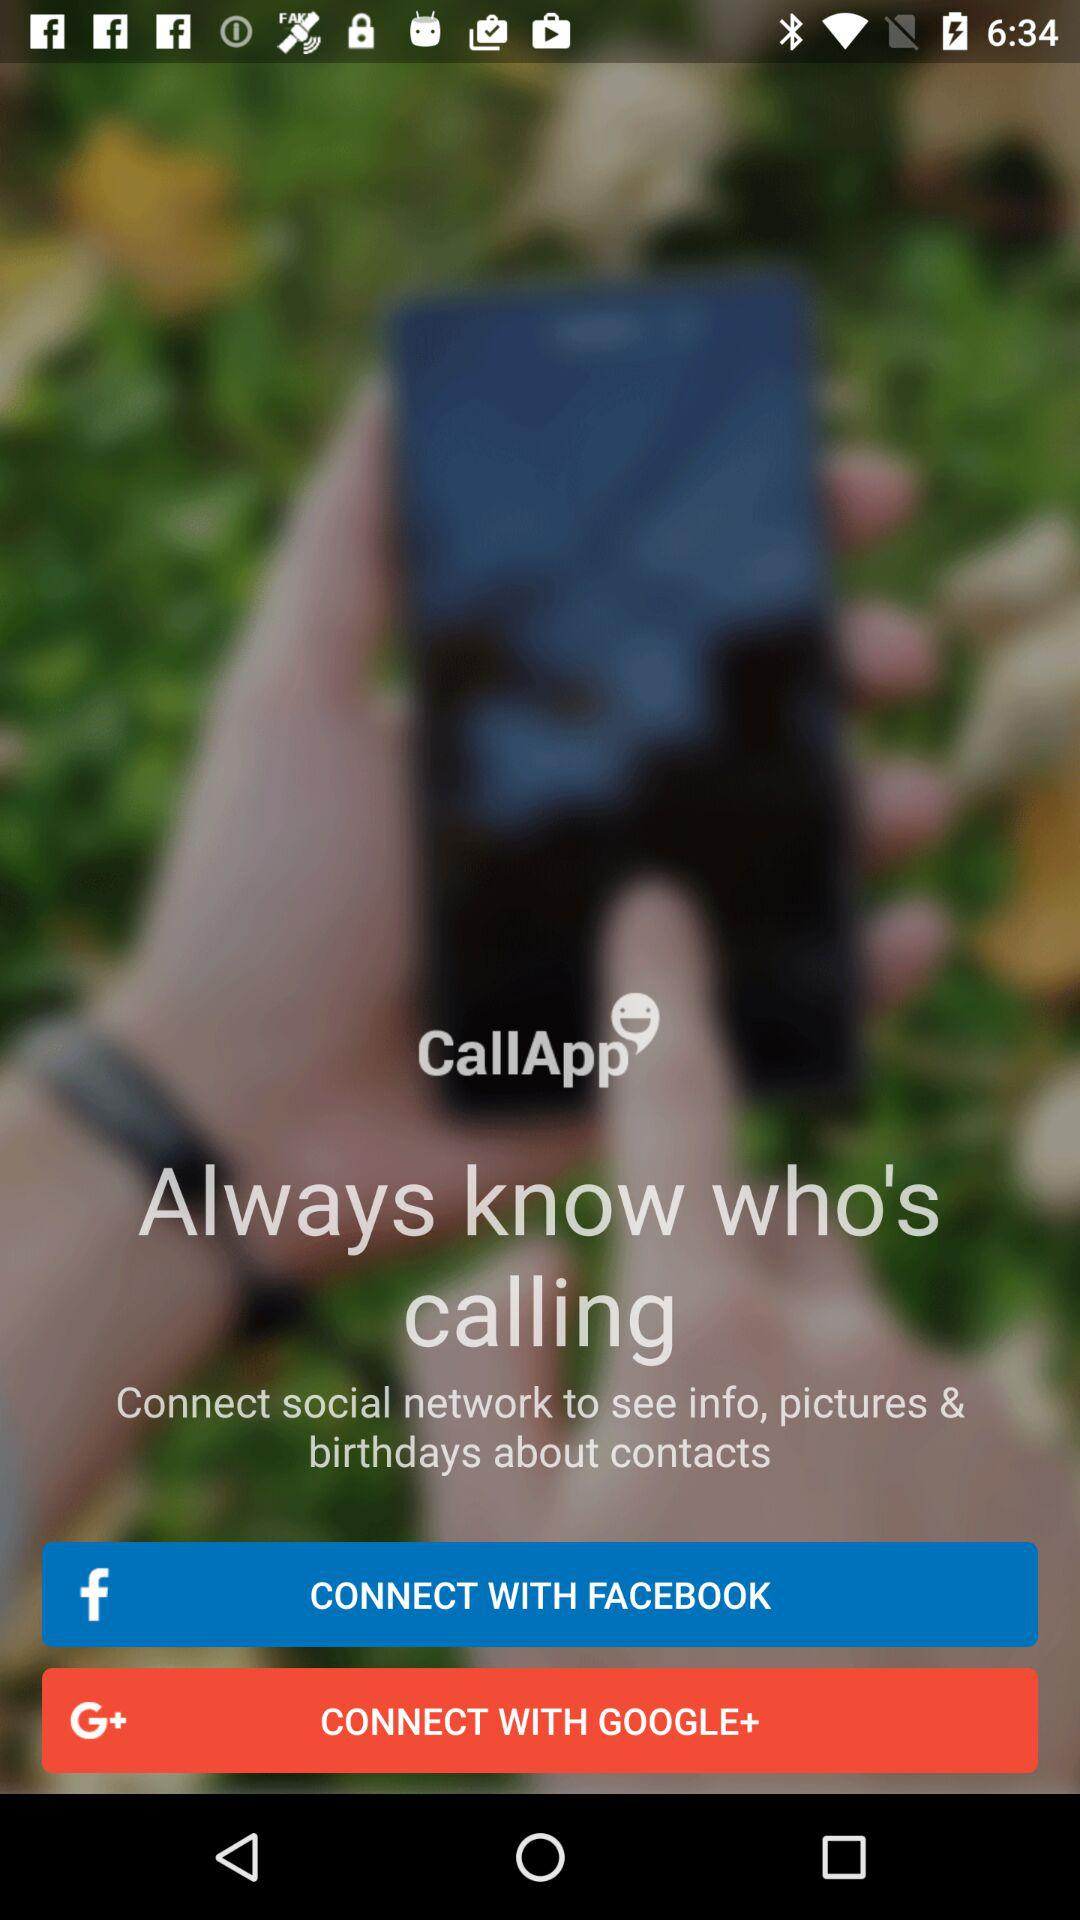How many social networks can I connect to see information about contacts?
Answer the question using a single word or phrase. 2 